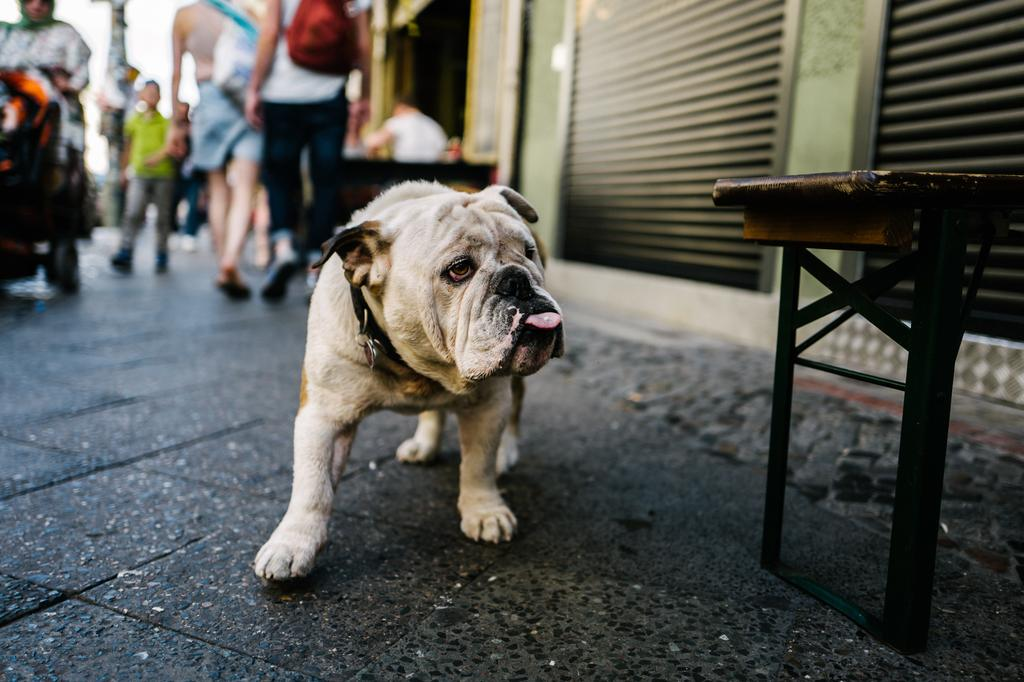What animal can be seen in the picture? There is a dog in the picture. How is the dog being emphasized in the image? The dog is highlighted in the picture. What type of furniture is present in the image? There is a table in the picture. What type of establishments are visible in the image? There are stores in the picture. What are the humans in the image doing? Humans are walking on the road in the image. Can you describe any movement visible in the picture? There is leg movement visible in the picture. What type of account is being discussed in the picture? There is no mention of an account in the image; it features a dog, a table, stores, humans, and leg movement. Can you see a camp in the picture? There is no camp present in the image. 